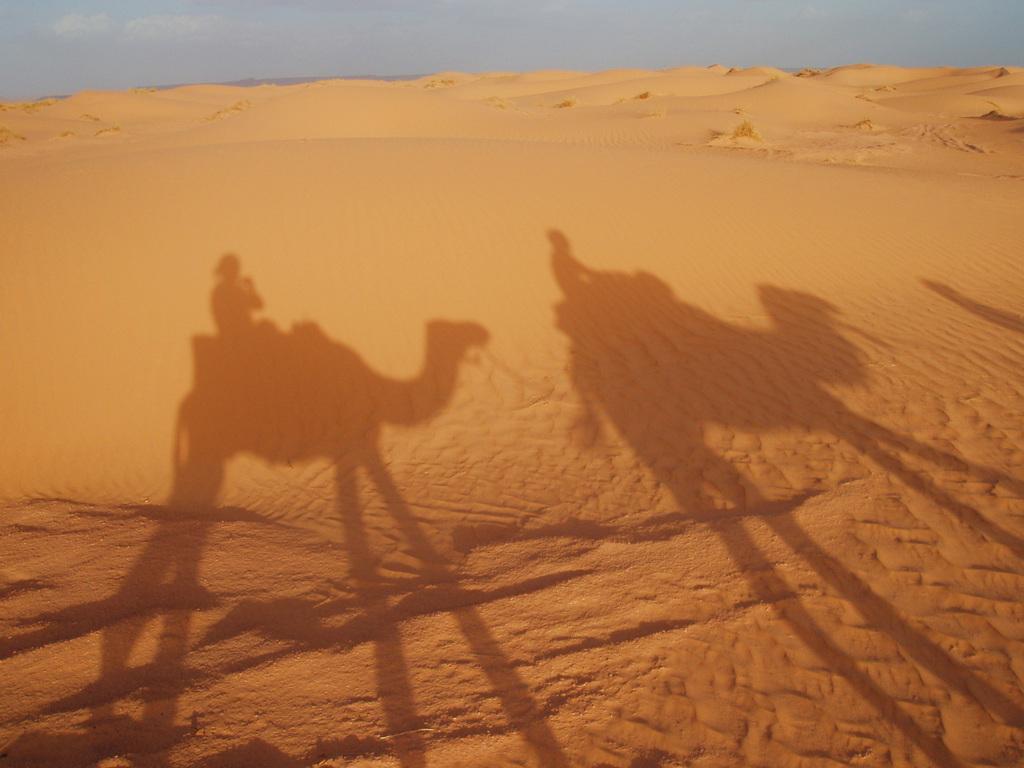Can you describe this image briefly? In the image we can see everywhere there is a sand. On the sand, we can shadow of two camels and persons are sitting on it. We can even see a cloudy sky. 